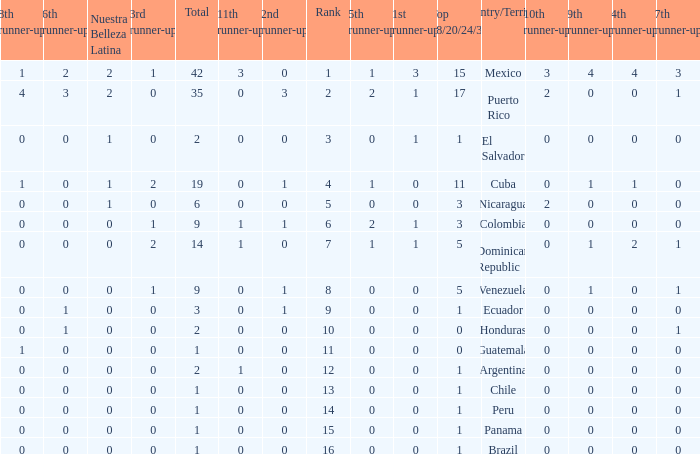What is the average total of the country with a 4th runner-up of 0 and a Nuestra Bellaza Latina less than 0? None. 